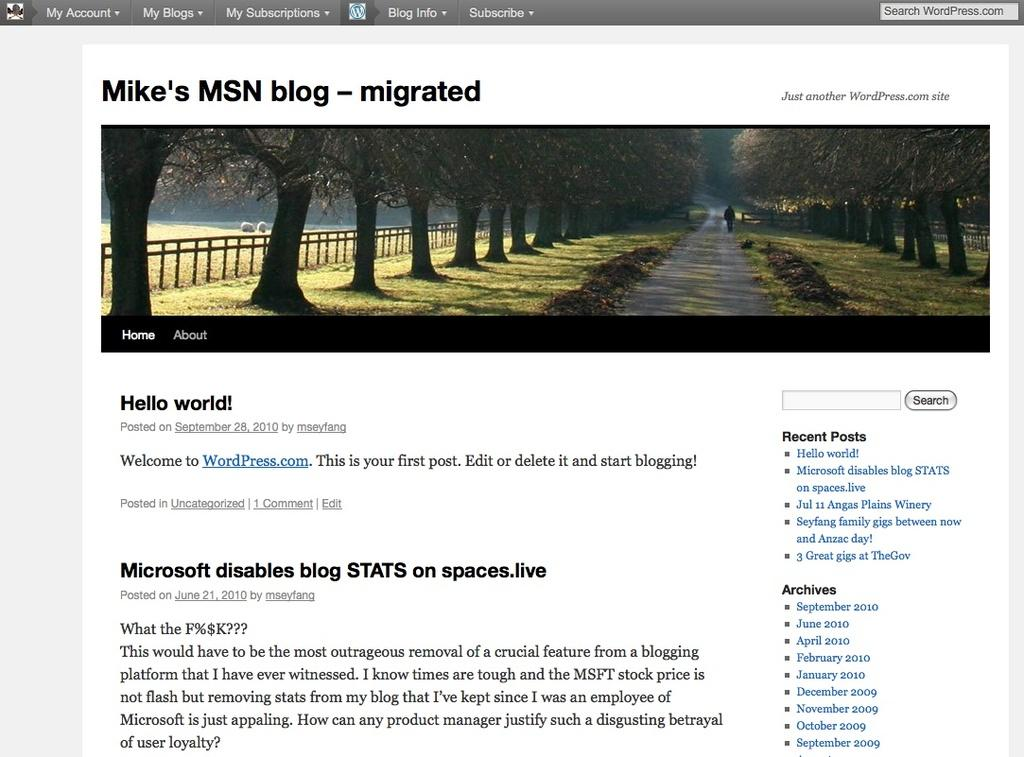What type of natural elements can be seen in the image? There are trees in the image. What man-made structure is visible in the image? There is a road and a fence in the image. What is the person in the image doing? A person is walking on the road in the image. Can you describe any text present in the image? There is text at the top and bottom of the image. What type of boundary can be seen between the trees and the road in the image? There is no specific boundary between the trees and the road in the image; the fence is located near the trees but not between them and the road. Can you tell me how many oceans are visible in the image? There are no oceans present in the image; it features trees, a road, a fence, and a person walking. 